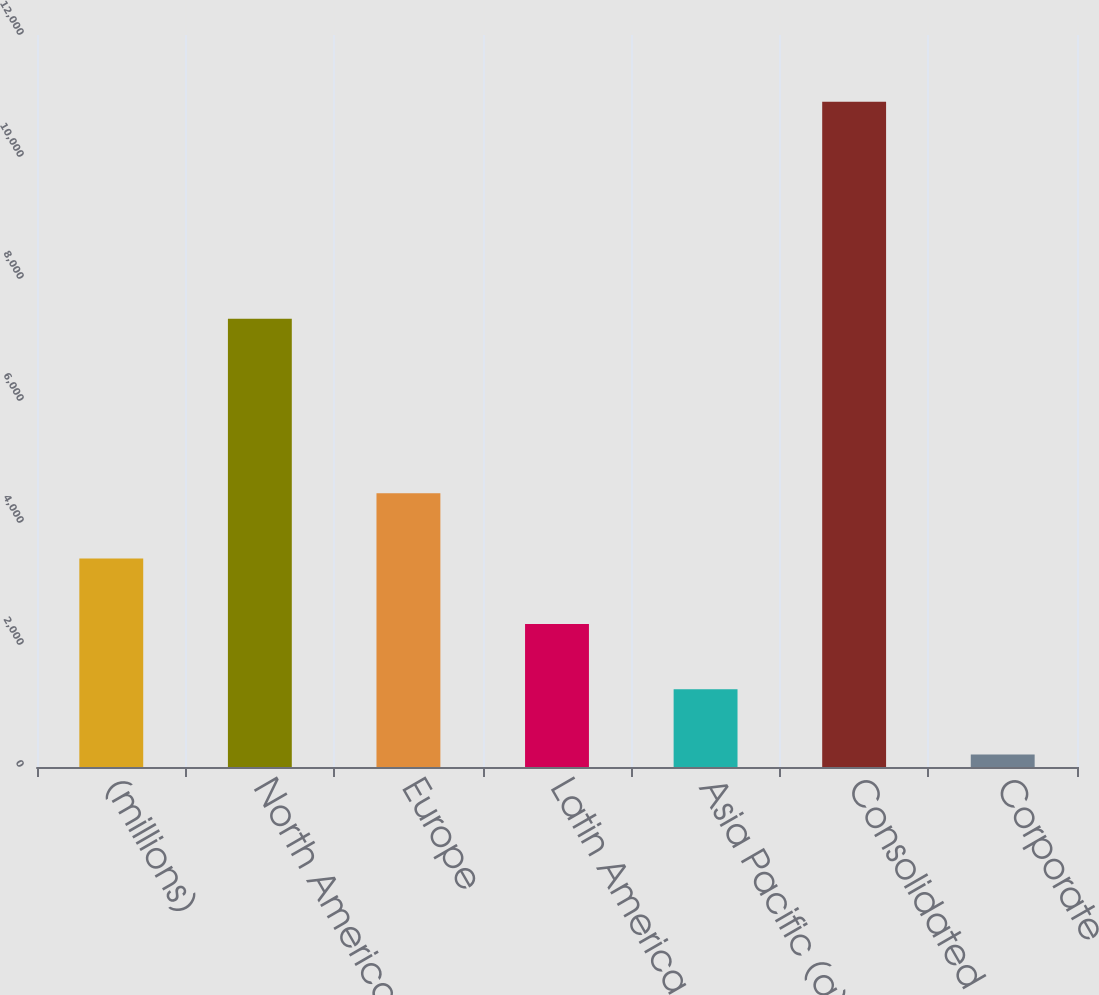Convert chart. <chart><loc_0><loc_0><loc_500><loc_500><bar_chart><fcel>(millions)<fcel>North America<fcel>Europe<fcel>Latin America<fcel>Asia Pacific (a)<fcel>Consolidated<fcel>Corporate<nl><fcel>3416.07<fcel>7348.8<fcel>4486.16<fcel>2345.98<fcel>1275.89<fcel>10906.7<fcel>205.8<nl></chart> 